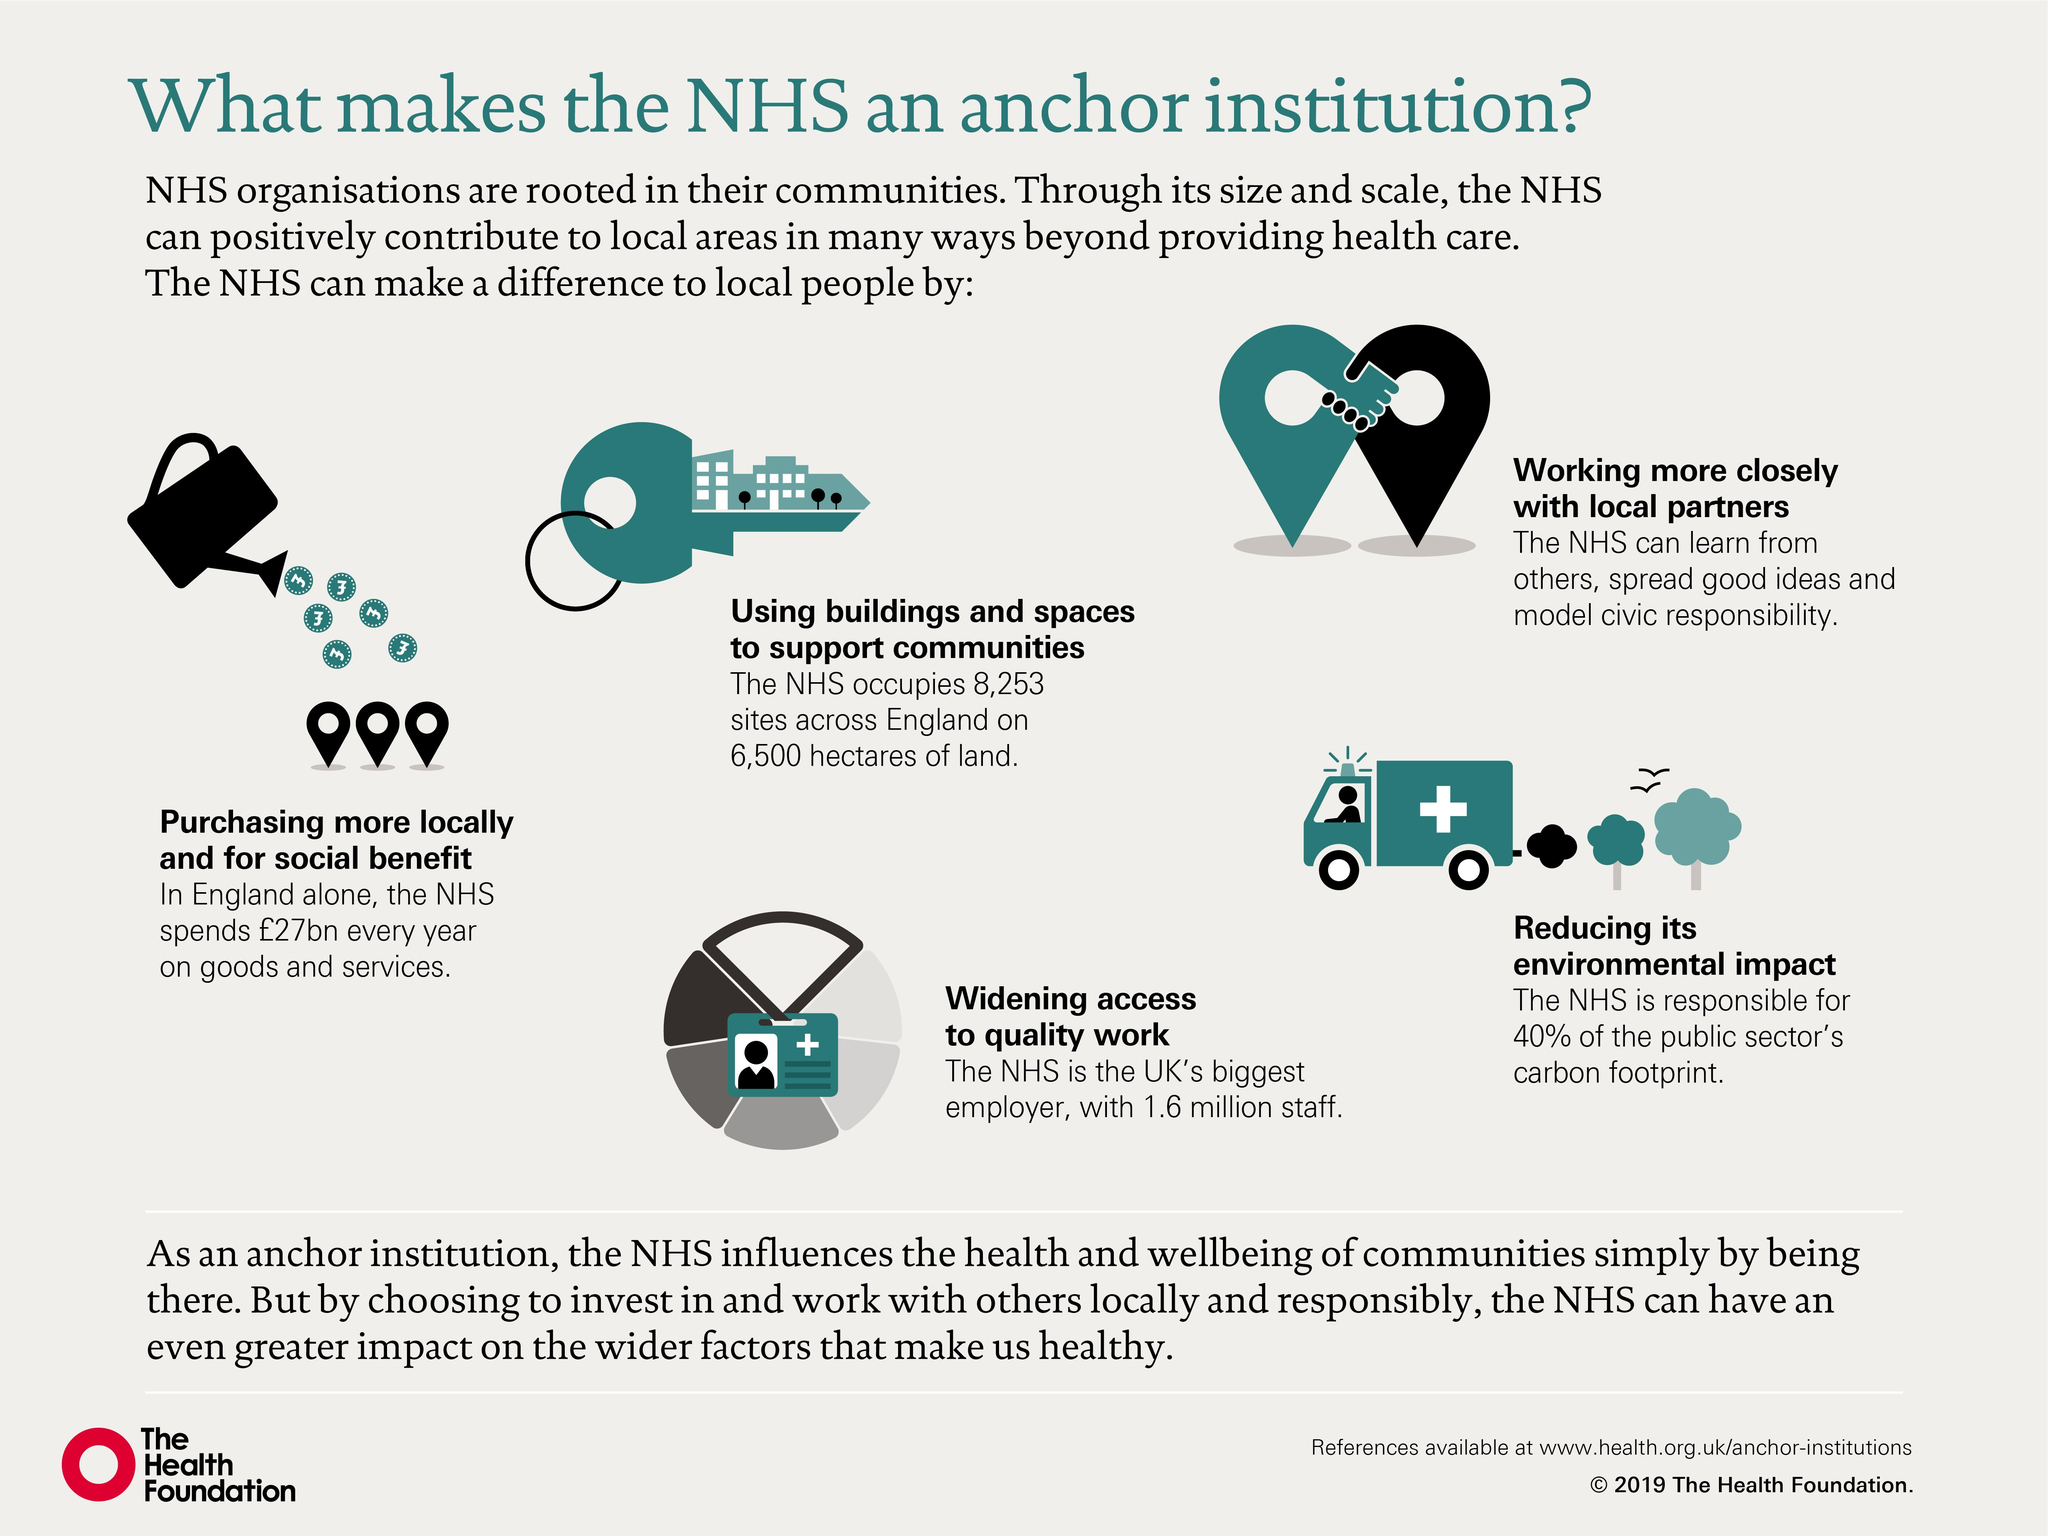Indicate a few pertinent items in this graphic. The National Health Service (NHS) is responsible for approximately 40% of the public sector's total carbon footprint. The NHS employs approximately 1.6 million staff. 